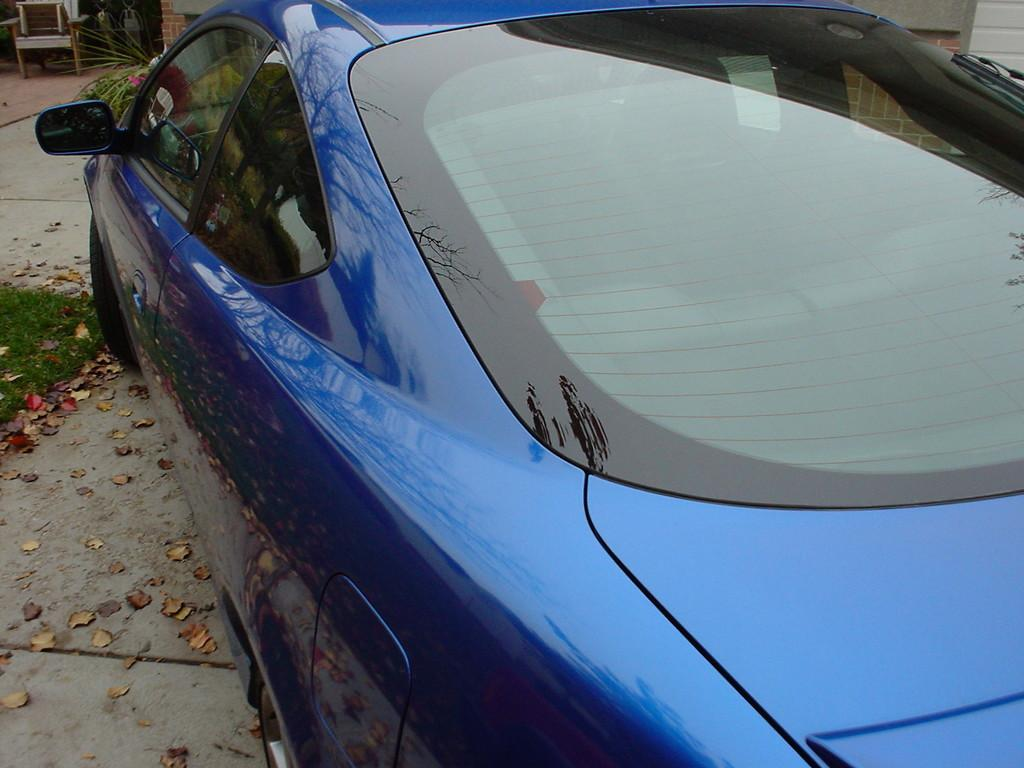What is the main subject of the image? The main subject of the image is a car. Where is the car located in the image? The car is on a road. What type of game is being played in the church in the image? There is no game or church present in the image; it only features a car on a road. 